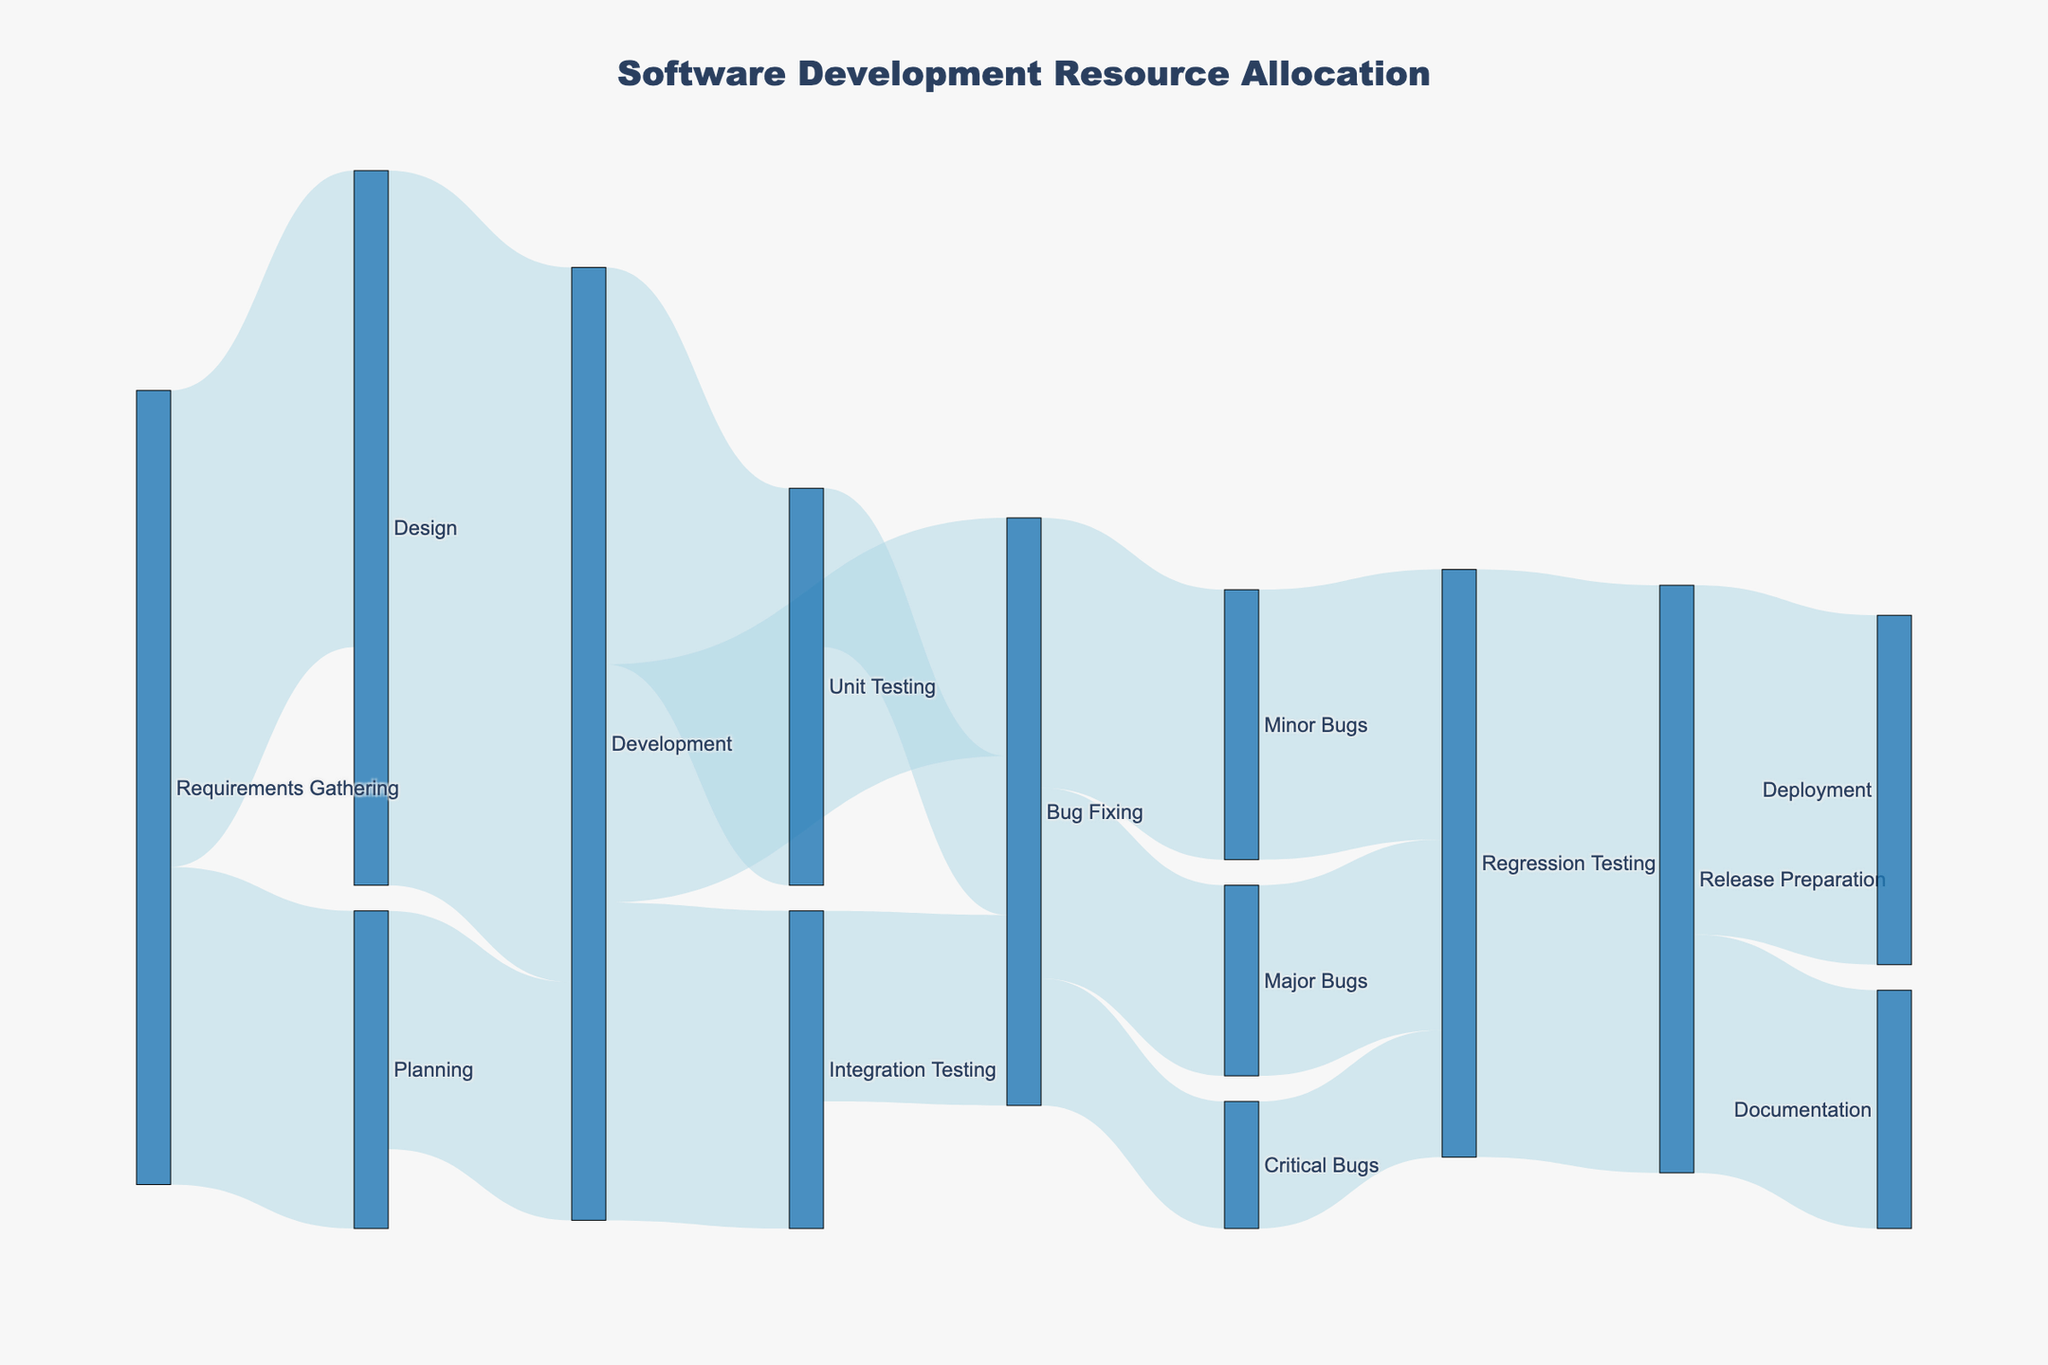How many resources are allocated from Requirements Gathering to Design? Look at the flow from Requirements Gathering to Design in the Sankey diagram. The value at the link represents the number of resources.
Answer: 30 What is the total number of resources allocated from Development to all its subsequent phases? To find the sum of resources allocated from Development, add the values of all the outgoing flows from Development: 25 (to Unit Testing) + 20 (to Integration Testing) + 15 (to Bug Fixing).
Answer: 60 Which phase receives the highest number of resources from Bug Fixing? Examine the outgoing flows from Bug Fixing to find the maximum value. Bug Fixing allocates resources as follows: 8 (to Critical Bugs), 12 (to Major Bugs), and 17 (to Minor Bugs).
Answer: Minor Bugs What is the number of resources that flow from Planning to Development compared to from Design to Development? Look at the outgoing flow from Planning to Development (15) and compare it with the flow from Design to Development (45).
Answer: Design to Development has more resources (45 vs. 15) By how much does the allocation to Regression Testing from Critical Bugs, Major Bugs, and Minor Bugs differ? The total resources flowing into Regression Testing are the sum of values from Critical Bugs, Major Bugs, and Minor Bugs: 8 (from Critical Bugs) + 12 (from Major Bugs) + 17 (from Minor Bugs).
Answer: 37 How many total resources are involved in Bug Fixing activities? Sum all the resources allocated to Critical Bugs, Major Bugs, and Minor Bugs from Bug Fixing: 8 (Critical Bugs) + 12 (Major Bugs) + 17 (Minor Bugs).
Answer: 37 What proportion of the resources from Development are allocated to Integration Testing? Calculate the percentage of resources from Development going to Integration Testing: (20/60) * 100%.
Answer: ~33.33% What is the difference in resource allocation between Release Preparation to Documentation and Deployment? Check the values for Release Preparation to Documentation (15) and Release Preparation to Deployment (22) and find the difference.
Answer: 7 Does Regression Testing receive more resources from Major Bugs or from the cumulative bugs in Bug Fixing? Compare the incoming resources to Regression Testing from Major Bugs (12) with the cumulative sum of Bug Fixing (37).
Answer: Cumulative Bug Fixing Is the flow of resources from Requirements Gathering to Planning larger or smaller than from Design to Development? Compare the flow from Requirements Gathering to Planning (20) with Design to Development (45).
Answer: Smaller 